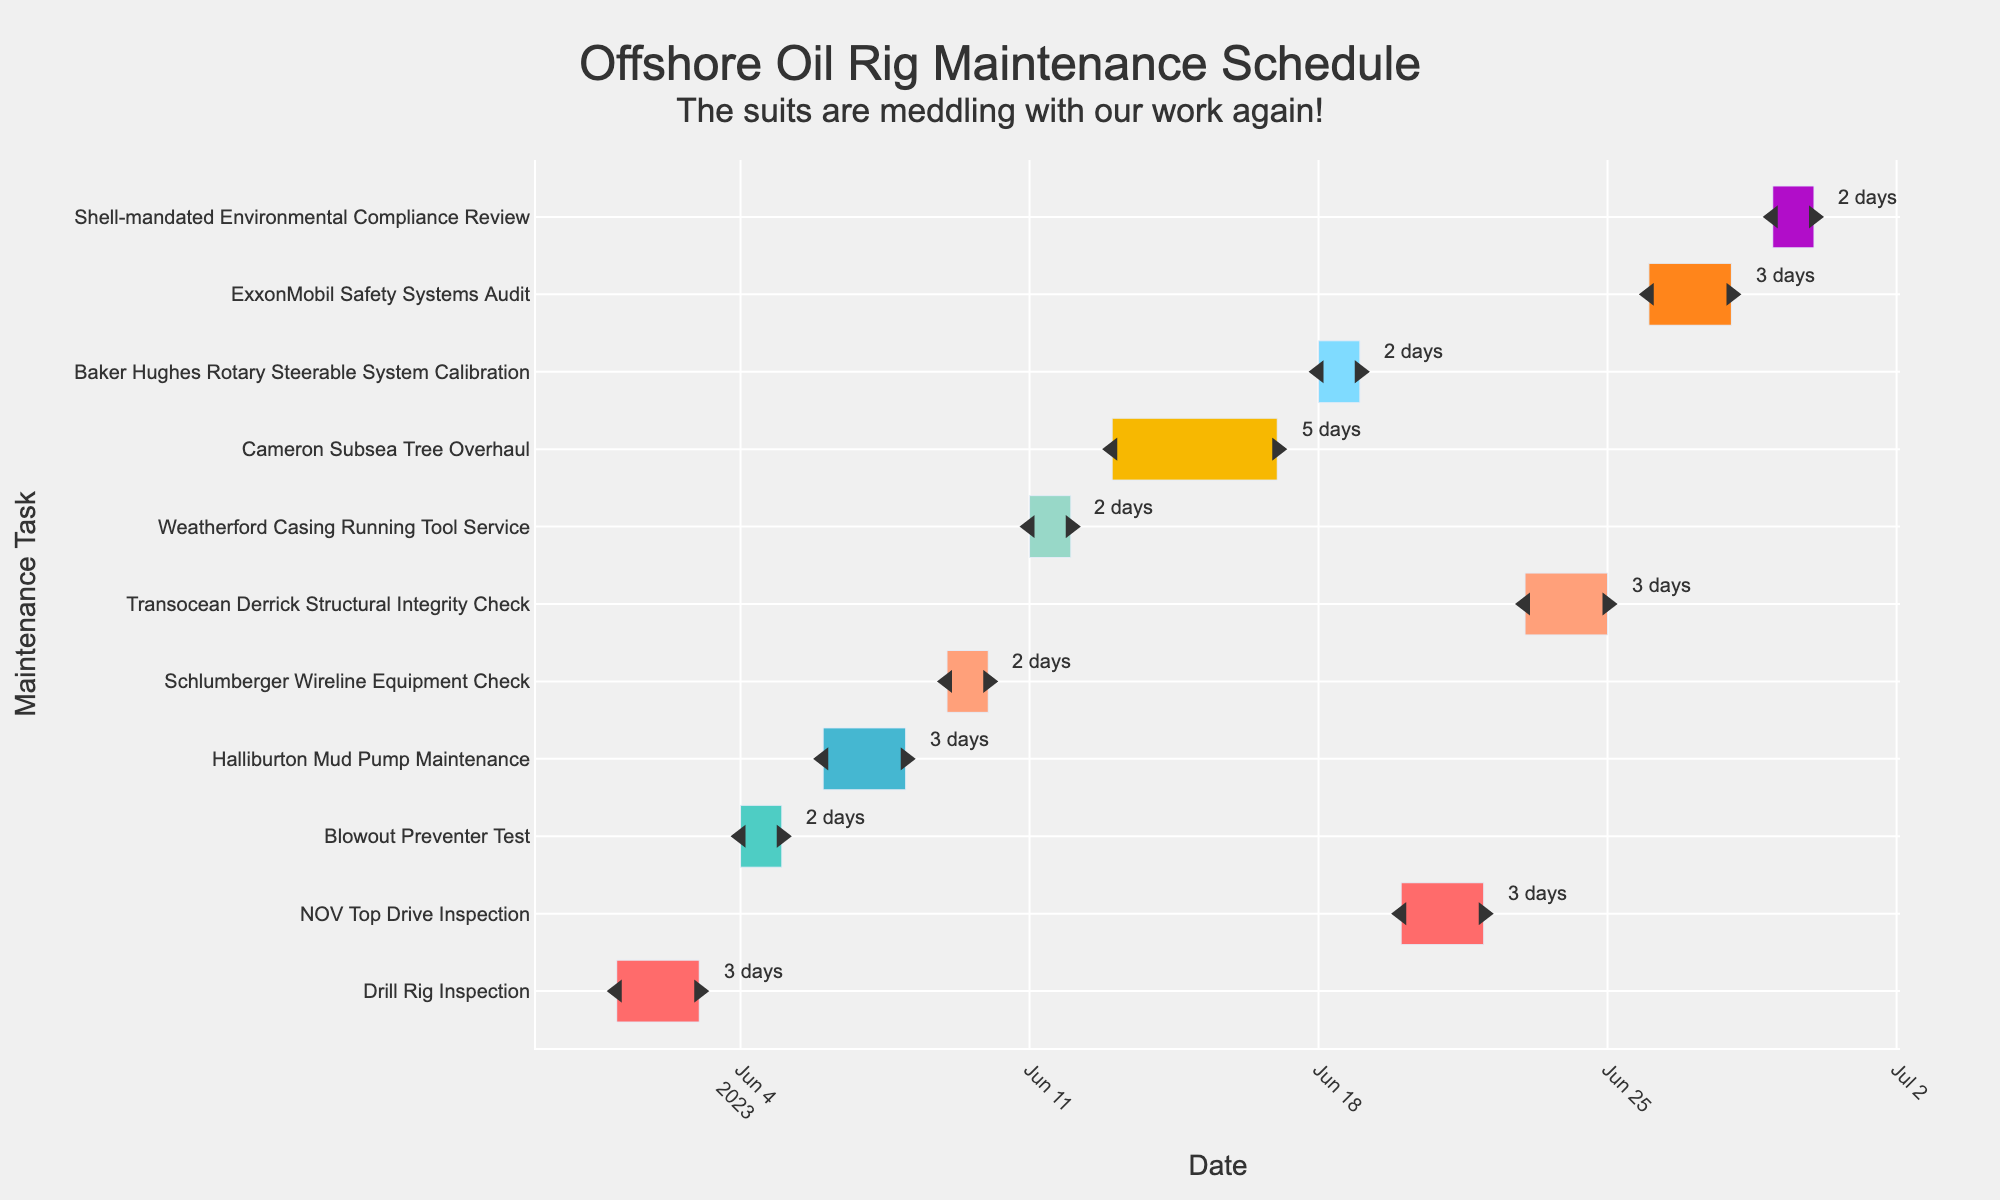What is the duration of the "Drill Rig Inspection" task? The "Drill Rig Inspection" task starts on June 1 and ends on June 3, which makes its duration 3 days.
Answer: 3 days How many tasks are scheduled for June 15? To answer this, we need to look at the tasks and check how many are in progress on June 15. Only the "Cameron Subsea Tree Overhaul" spans June 15.
Answer: 1 Which task takes the longest duration? Comparing the durations of all tasks, the "Cameron Subsea Tree Overhaul" has the longest duration at 5 days.
Answer: Cameron Subsea Tree Overhaul How does the "Blowout Preventer Test" compare in duration to the "NOV Top Drive Inspection"? The "Blowout Preventer Test" lasts for 2 days, whereas the "NOV Top Drive Inspection" lasts for 3 days. Thus, the "NOV Top Drive Inspection" is longer.
Answer: NOV Top Drive Inspection What are the start and end dates for the "Baker Hughes Rotary Steerable System Calibration"? The "Baker Hughes Rotary Steerable System Calibration" starts on June 18 and ends on June 19.
Answer: June 18 - June 19 Which task begins immediately after the "Weatherford Casing Running Tool Service"? The "Cameron Subsea Tree Overhaul" starts immediately after the "Weatherford Casing Running Tool Service."
Answer: Cameron Subsea Tree Overhaul How many tasks take exactly 2 days? From the figure, "Blowout Preventer Test," "Schlumberger Wireline Equipment Check," "Weatherford Casing Running Tool Service," "Baker Hughes Rotary Steerable System Calibration," and "Shell-mandated Environmental Compliance Review" each take 2 days. Thus, there are 5 tasks of exactly 2 days each.
Answer: 5 What is the total duration of tasks starting after June 20? The tasks starting after June 20 are "Transocean Derrick Structural Integrity Check" (3 days), "ExxonMobil Safety Systems Audit" (3 days), and "Shell-mandated Environmental Compliance Review" (2 days). Summing these durations, we get 3 + 3 + 2 = 8 days.
Answer: 8 days Which task has the latest starting date? The "Shell-mandated Environmental Compliance Review" has the latest starting date of June 29.
Answer: Shell-mandated Environmental Compliance Review What maintenance tasks are performed by Halliburton, Schlumberger, and Weatherford? From the figure, "Halliburton Mud Pump Maintenance," "Schlumberger Wireline Equipment Check," and "Weatherford Casing Running Tool Service" are the tasks performed by Halliburton, Schlumberger, and Weatherford respectively.
Answer: Halliburton Mud Pump Maintenance, Schlumberger Wireline Equipment Check, Weatherford Casing Running Tool Service 